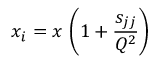<formula> <loc_0><loc_0><loc_500><loc_500>x _ { i } = x \, \left ( 1 + \frac { { s _ { j j } } } { Q ^ { 2 } } \right )</formula> 